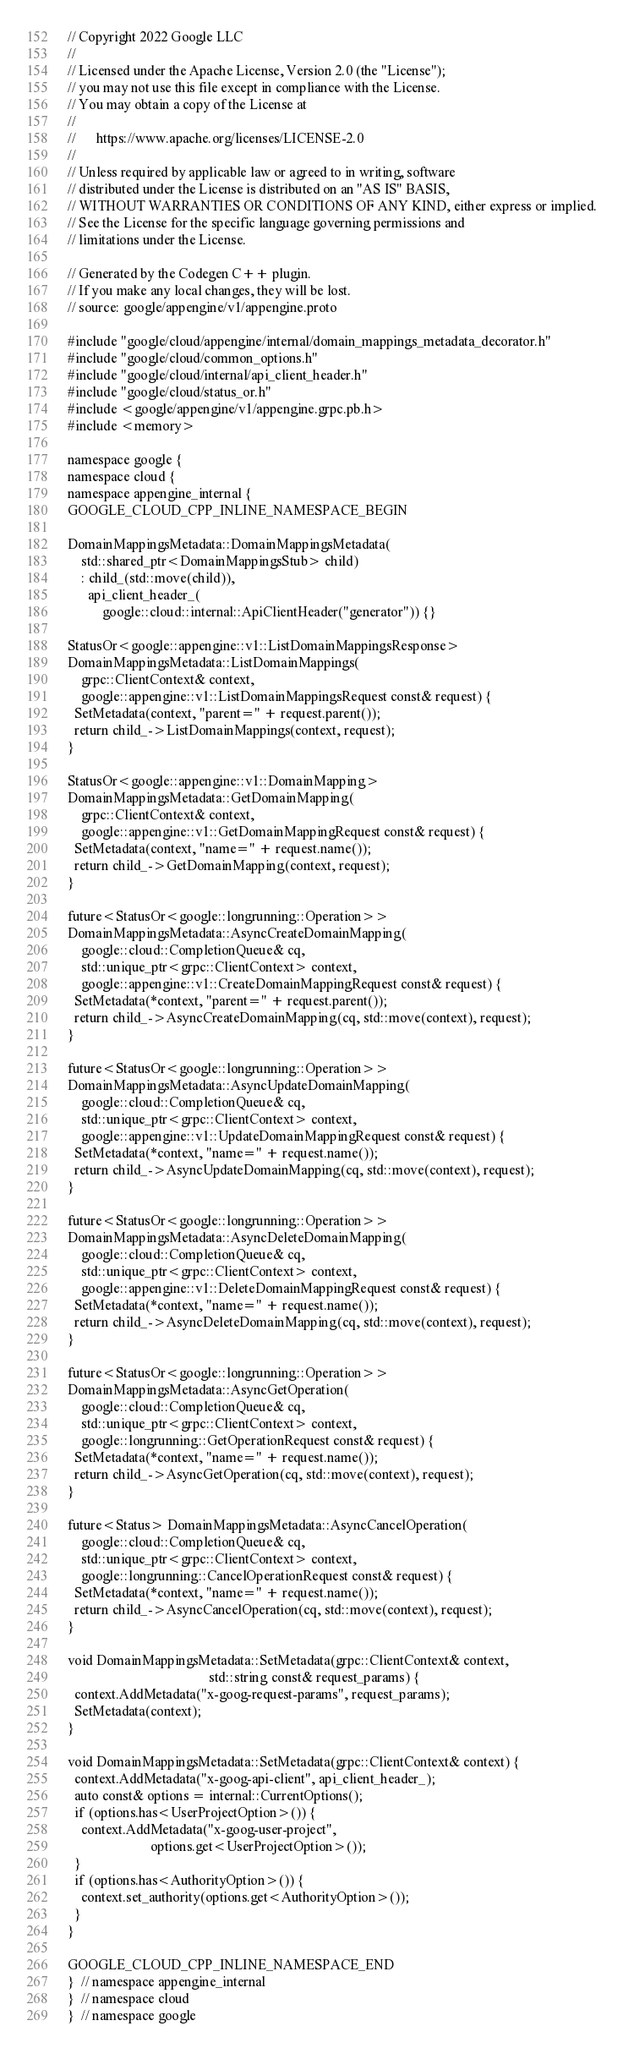Convert code to text. <code><loc_0><loc_0><loc_500><loc_500><_C++_>// Copyright 2022 Google LLC
//
// Licensed under the Apache License, Version 2.0 (the "License");
// you may not use this file except in compliance with the License.
// You may obtain a copy of the License at
//
//      https://www.apache.org/licenses/LICENSE-2.0
//
// Unless required by applicable law or agreed to in writing, software
// distributed under the License is distributed on an "AS IS" BASIS,
// WITHOUT WARRANTIES OR CONDITIONS OF ANY KIND, either express or implied.
// See the License for the specific language governing permissions and
// limitations under the License.

// Generated by the Codegen C++ plugin.
// If you make any local changes, they will be lost.
// source: google/appengine/v1/appengine.proto

#include "google/cloud/appengine/internal/domain_mappings_metadata_decorator.h"
#include "google/cloud/common_options.h"
#include "google/cloud/internal/api_client_header.h"
#include "google/cloud/status_or.h"
#include <google/appengine/v1/appengine.grpc.pb.h>
#include <memory>

namespace google {
namespace cloud {
namespace appengine_internal {
GOOGLE_CLOUD_CPP_INLINE_NAMESPACE_BEGIN

DomainMappingsMetadata::DomainMappingsMetadata(
    std::shared_ptr<DomainMappingsStub> child)
    : child_(std::move(child)),
      api_client_header_(
          google::cloud::internal::ApiClientHeader("generator")) {}

StatusOr<google::appengine::v1::ListDomainMappingsResponse>
DomainMappingsMetadata::ListDomainMappings(
    grpc::ClientContext& context,
    google::appengine::v1::ListDomainMappingsRequest const& request) {
  SetMetadata(context, "parent=" + request.parent());
  return child_->ListDomainMappings(context, request);
}

StatusOr<google::appengine::v1::DomainMapping>
DomainMappingsMetadata::GetDomainMapping(
    grpc::ClientContext& context,
    google::appengine::v1::GetDomainMappingRequest const& request) {
  SetMetadata(context, "name=" + request.name());
  return child_->GetDomainMapping(context, request);
}

future<StatusOr<google::longrunning::Operation>>
DomainMappingsMetadata::AsyncCreateDomainMapping(
    google::cloud::CompletionQueue& cq,
    std::unique_ptr<grpc::ClientContext> context,
    google::appengine::v1::CreateDomainMappingRequest const& request) {
  SetMetadata(*context, "parent=" + request.parent());
  return child_->AsyncCreateDomainMapping(cq, std::move(context), request);
}

future<StatusOr<google::longrunning::Operation>>
DomainMappingsMetadata::AsyncUpdateDomainMapping(
    google::cloud::CompletionQueue& cq,
    std::unique_ptr<grpc::ClientContext> context,
    google::appengine::v1::UpdateDomainMappingRequest const& request) {
  SetMetadata(*context, "name=" + request.name());
  return child_->AsyncUpdateDomainMapping(cq, std::move(context), request);
}

future<StatusOr<google::longrunning::Operation>>
DomainMappingsMetadata::AsyncDeleteDomainMapping(
    google::cloud::CompletionQueue& cq,
    std::unique_ptr<grpc::ClientContext> context,
    google::appengine::v1::DeleteDomainMappingRequest const& request) {
  SetMetadata(*context, "name=" + request.name());
  return child_->AsyncDeleteDomainMapping(cq, std::move(context), request);
}

future<StatusOr<google::longrunning::Operation>>
DomainMappingsMetadata::AsyncGetOperation(
    google::cloud::CompletionQueue& cq,
    std::unique_ptr<grpc::ClientContext> context,
    google::longrunning::GetOperationRequest const& request) {
  SetMetadata(*context, "name=" + request.name());
  return child_->AsyncGetOperation(cq, std::move(context), request);
}

future<Status> DomainMappingsMetadata::AsyncCancelOperation(
    google::cloud::CompletionQueue& cq,
    std::unique_ptr<grpc::ClientContext> context,
    google::longrunning::CancelOperationRequest const& request) {
  SetMetadata(*context, "name=" + request.name());
  return child_->AsyncCancelOperation(cq, std::move(context), request);
}

void DomainMappingsMetadata::SetMetadata(grpc::ClientContext& context,
                                         std::string const& request_params) {
  context.AddMetadata("x-goog-request-params", request_params);
  SetMetadata(context);
}

void DomainMappingsMetadata::SetMetadata(grpc::ClientContext& context) {
  context.AddMetadata("x-goog-api-client", api_client_header_);
  auto const& options = internal::CurrentOptions();
  if (options.has<UserProjectOption>()) {
    context.AddMetadata("x-goog-user-project",
                        options.get<UserProjectOption>());
  }
  if (options.has<AuthorityOption>()) {
    context.set_authority(options.get<AuthorityOption>());
  }
}

GOOGLE_CLOUD_CPP_INLINE_NAMESPACE_END
}  // namespace appengine_internal
}  // namespace cloud
}  // namespace google
</code> 